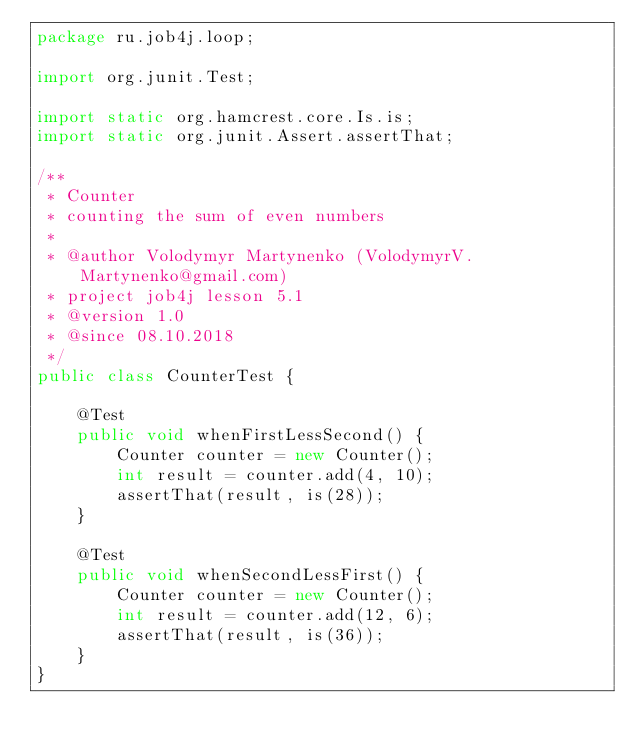Convert code to text. <code><loc_0><loc_0><loc_500><loc_500><_Java_>package ru.job4j.loop;

import org.junit.Test;

import static org.hamcrest.core.Is.is;
import static org.junit.Assert.assertThat;

/**
 * Counter
 * counting the sum of even numbers
 *
 * @author Volodymyr Martynenko (VolodymyrV.Martynenko@gmail.com)
 * project job4j lesson 5.1
 * @version 1.0
 * @since 08.10.2018
 */
public class CounterTest {

    @Test
    public void whenFirstLessSecond() {
        Counter counter = new Counter();
        int result = counter.add(4, 10);
        assertThat(result, is(28));
    }

    @Test
    public void whenSecondLessFirst() {
        Counter counter = new Counter();
        int result = counter.add(12, 6);
        assertThat(result, is(36));
    }
}
</code> 